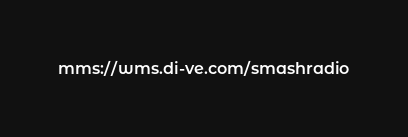Convert code to text. <code><loc_0><loc_0><loc_500><loc_500><_SQL_>mms://wms.di-ve.com/smashradio
</code> 